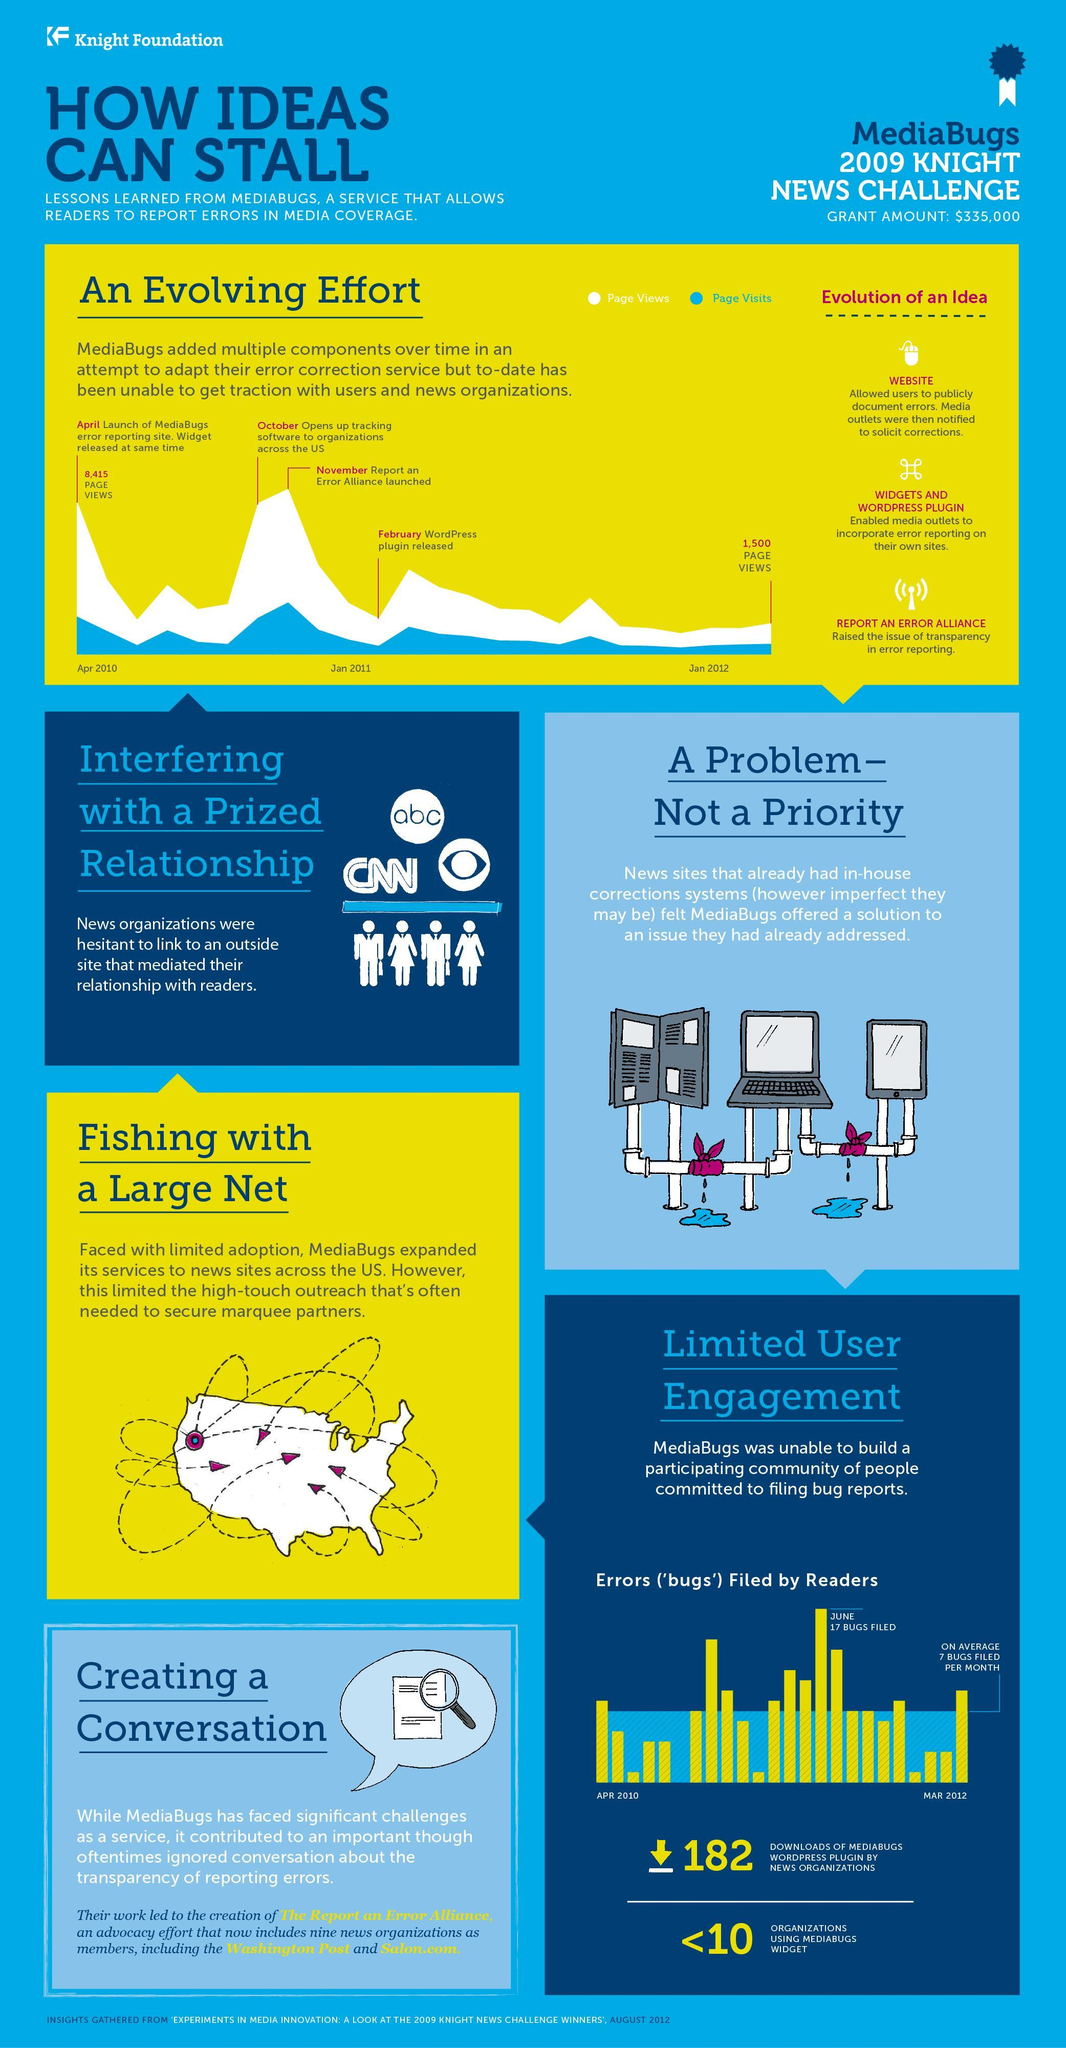Which year was the WordPress plugin released, 2010, 2011, or 2012?
Answer the question with a short phrase. 2011 Which year was the maximum number of media bugs filed, 2012, 2011, or 2010? 2011 Which month did not have any reports of bugs filed, September 2010, June 2011, or Mar 2012? September 2010 Which news organization has a logo showing the human eye, CNN, ABC, or CBS? CBS What is the decrease in page views from Apr 2010 to Apr 2012 ? 6,915 